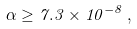Convert formula to latex. <formula><loc_0><loc_0><loc_500><loc_500>\alpha \geq 7 . 3 \times 1 0 ^ { - 8 } \, ,</formula> 